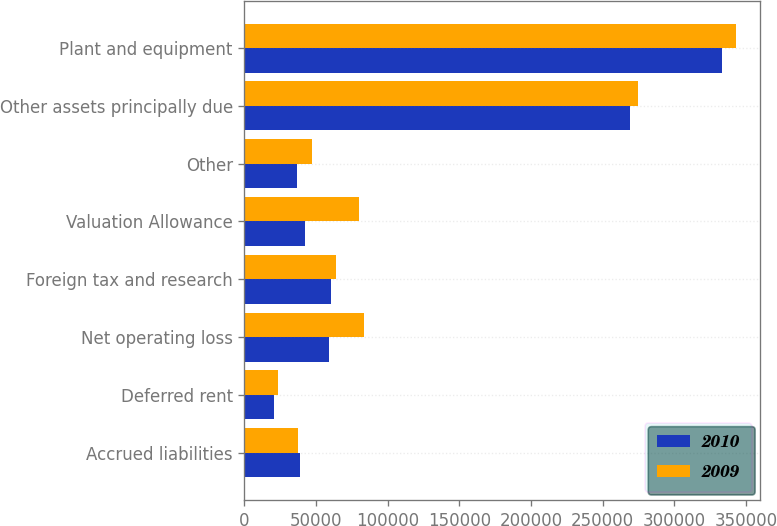<chart> <loc_0><loc_0><loc_500><loc_500><stacked_bar_chart><ecel><fcel>Accrued liabilities<fcel>Deferred rent<fcel>Net operating loss<fcel>Foreign tax and research<fcel>Valuation Allowance<fcel>Other<fcel>Other assets principally due<fcel>Plant and equipment<nl><fcel>2010<fcel>38919<fcel>20484<fcel>59330<fcel>60182<fcel>42128<fcel>36770<fcel>269452<fcel>333248<nl><fcel>2009<fcel>37273<fcel>23253<fcel>83204<fcel>64189<fcel>79863<fcel>47173<fcel>274959<fcel>342778<nl></chart> 